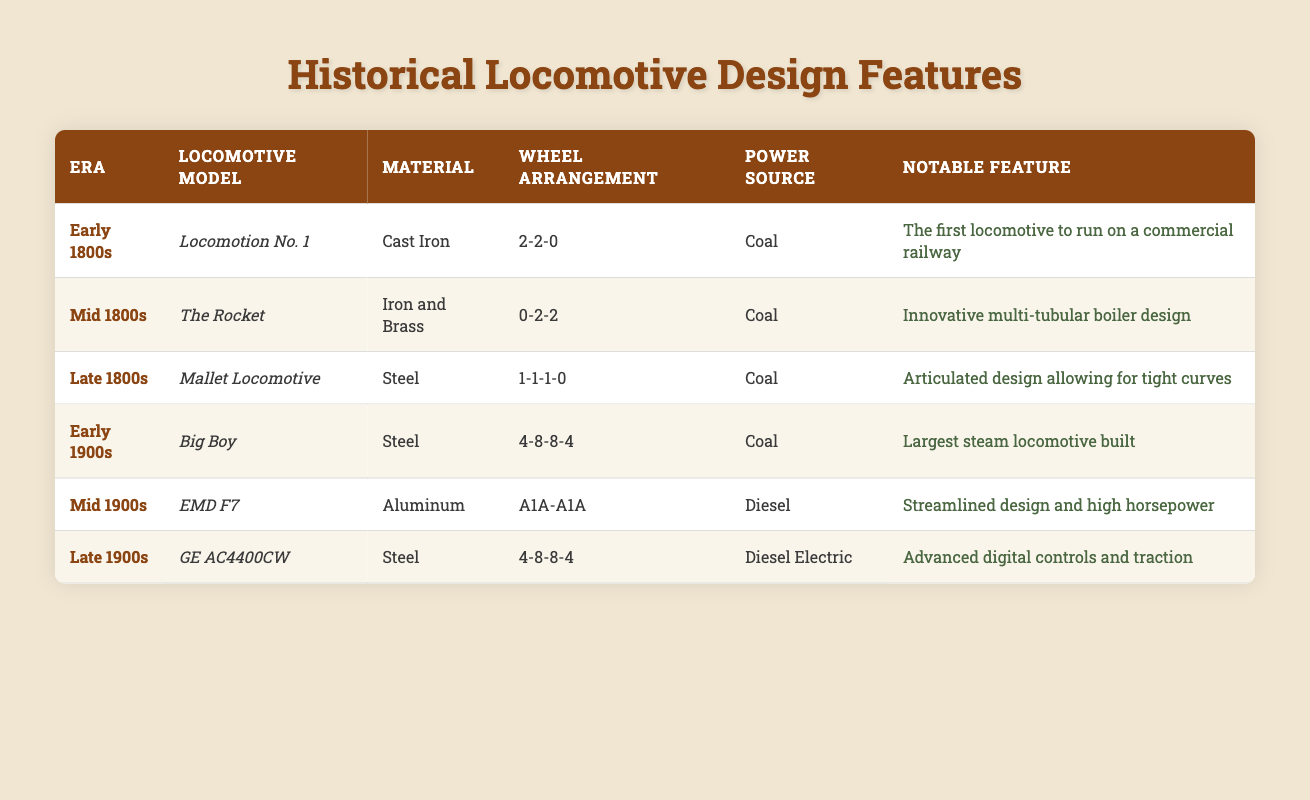What was the material used for the locomotive model "The Rocket"? Referring to the table, under the row for "The Rocket," the listed material is "Iron and Brass."
Answer: Iron and Brass Which locomotive model from the Early 1900s was noted as the "Largest steam locomotive built"? From the table, the locomotive model from the Early 1900s is "Big Boy," which has the notable feature of being the "Largest steam locomotive built."
Answer: Big Boy How many different wheel arrangements are listed in the table? The table lists three unique wheel arrangements: 2-2-0, 0-2-2, 1-1-1-0, 4-8-8-4, and A1A-A1A. Counting these gives us a total of five different arrangements.
Answer: 5 Did the Mallet Locomotive use a power source other than Coal? The Mallet Locomotive used Coal as its power source, according to the table. Thus the answer is no.
Answer: No Which era had the "Innovative multi-tubular boiler design" as a notable feature? Looking at the table, the notable feature "Innovative multi-tubular boiler design" corresponds to the locomotive model "The Rocket," which is from the Mid 1800s era.
Answer: Mid 1800s In which era and with what material was the "EMD F7" locomotive model built? According to the table, the "EMD F7" was built in the Mid 1900s using Aluminum.
Answer: Mid 1900s, Aluminum How does the power source of the Late 1800s locomotives compare to that of the Late 1900s locomotives? The Late 1800s locomotives primarily used Coal as their power source, while the Late 1900s locomotive, "GE AC4400CW," used Diesel Electric. This indicates a shift from coal to more modern power sources.
Answer: Coal vs. Diesel Electric What percentage of the listed locomotive models are powered by Coal? Among the six models listed, four are powered by Coal (Locomotion No. 1, The Rocket, Mallet Locomotive, Big Boy). The percentage is (4/6) * 100 = 66.67%.
Answer: 66.67% Which locomotive model has a higher horsepower feature, "Big Boy" or "EMD F7"? The table indicates that "EMD F7" features "Streamlined design and high horsepower," whereas "Big Boy" does not mention horsepower. However, "Big Boy" is known historically for its high power; thus, based on the table, we can say "EMD F7" explicitly mentions high horsepower while "Big Boy" does not.
Answer: EMD F7 